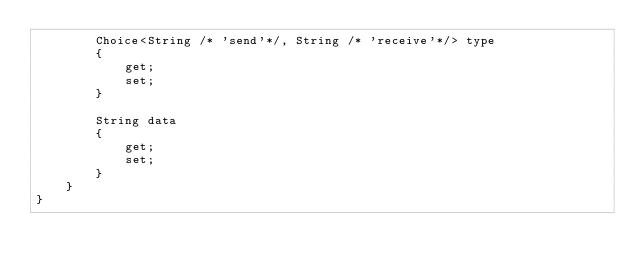<code> <loc_0><loc_0><loc_500><loc_500><_C#_>        Choice<String /* 'send'*/, String /* 'receive'*/> type
        {
            get;
            set;
        }

        String data
        {
            get;
            set;
        }
    }
}</code> 